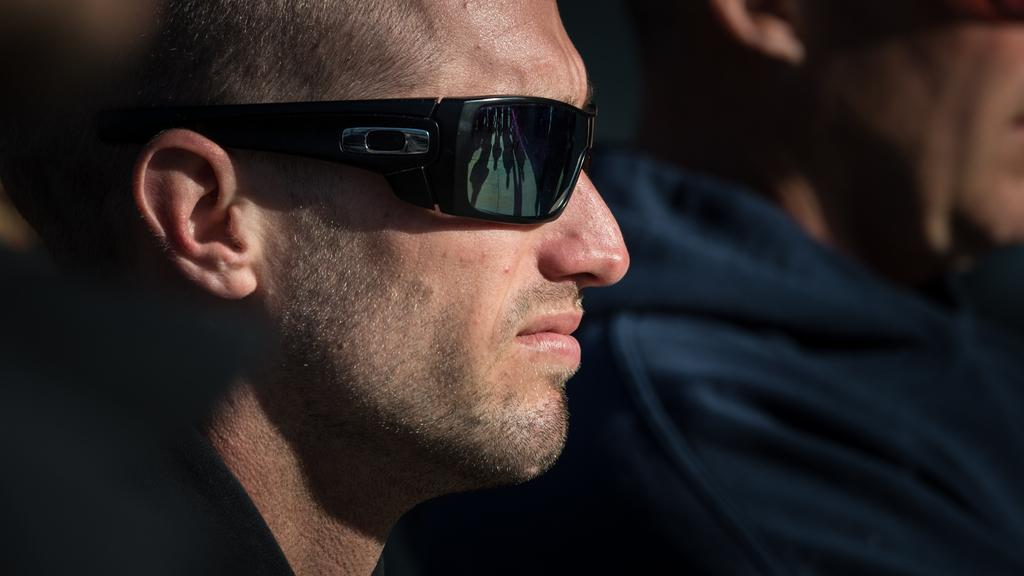Where is the first man located in the image? The first man is towards the left side of the image. What is the first man wearing on his face? The first man is wearing goggles. What color clothes is the first man wearing? The first man is wearing black clothes. Where is the second man located in the image? The second man is towards the right side of the image. What color clothes is the second man wearing? The second man is wearing blue clothes. What type of toothpaste is the man using in the image? There is no toothpaste present in the image; the man is wearing goggles and black clothes. Can you point out the railway in the image? There is no railway present in the image. 